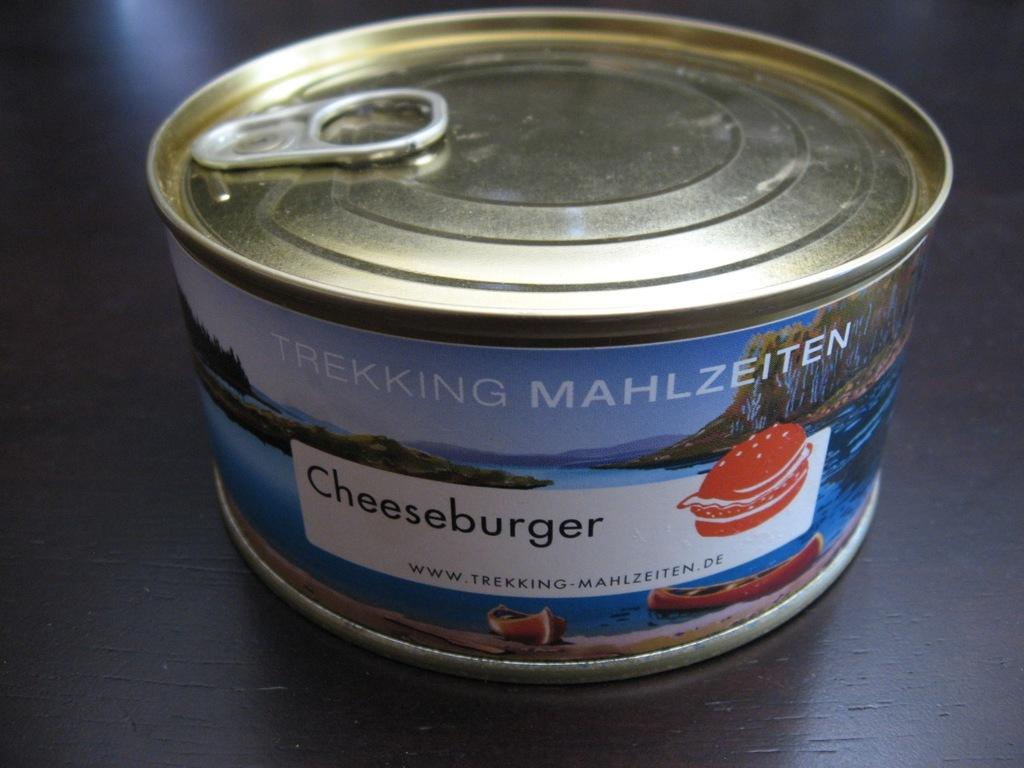<image>
Share a concise interpretation of the image provided. A small can of Trekking Mahlzeiten brand cheeseburger in a can. 